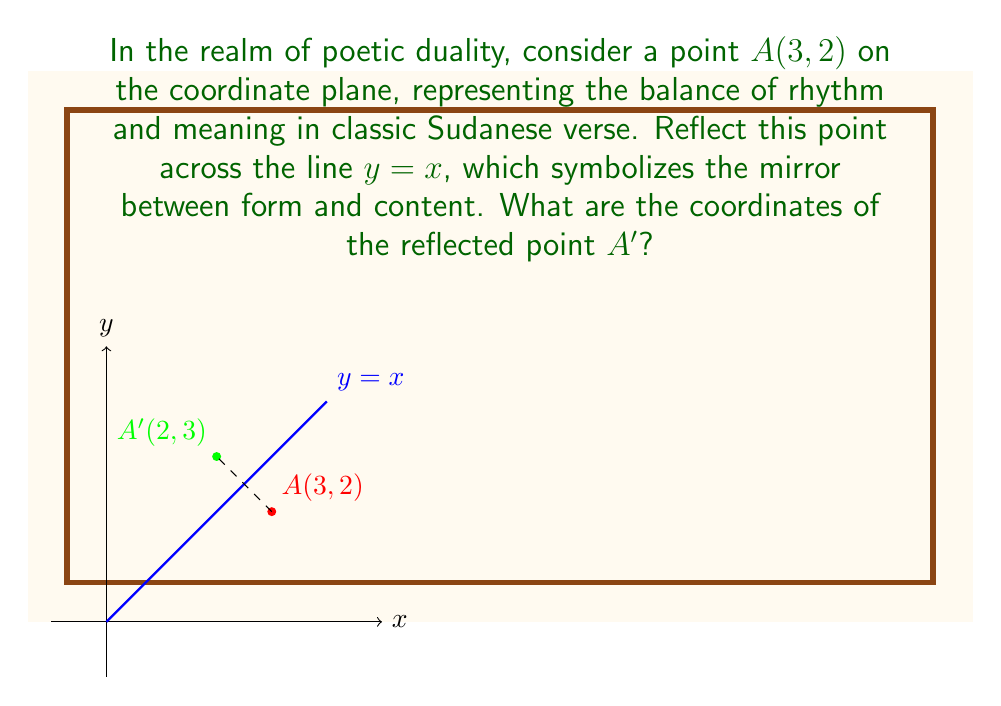What is the answer to this math problem? To reflect point $A(3, 2)$ across the line $y = x$, we follow these steps:

1) The line $y = x$ acts as a mirror. In a reflection across this line, the $x$ and $y$ coordinates of a point swap places.

2) For point $A(3, 2)$:
   - The $x$-coordinate is 3
   - The $y$-coordinate is 2

3) To reflect, we swap these coordinates:
   - The new $x$-coordinate becomes 2
   - The new $y$-coordinate becomes 3

4) Therefore, the reflected point $A'$ has coordinates $(2, 3)$

This reflection symbolizes the duality in Sudanese poetry, where form and content often mirror each other, creating a harmonious balance akin to the symmetry observed in this geometric transformation.
Answer: $A'(2, 3)$ 